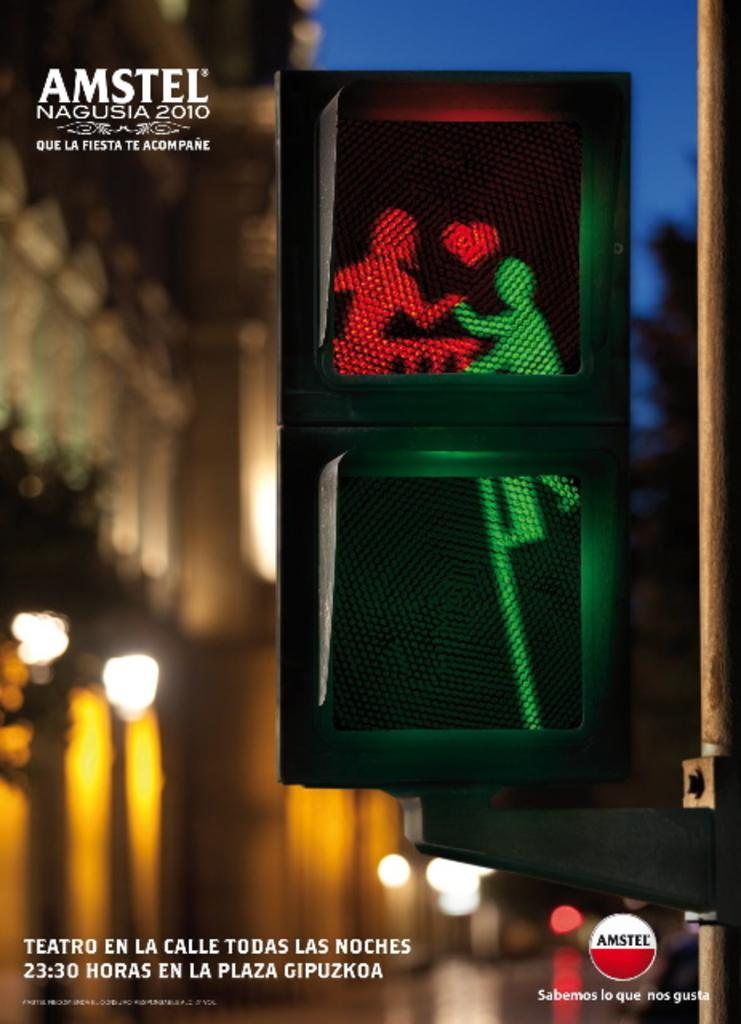<image>
Describe the image concisely. An advertisement in Spanish for Amstel Nagusia 2010. 